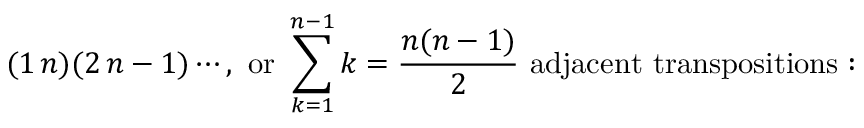Convert formula to latex. <formula><loc_0><loc_0><loc_500><loc_500>( 1 \, n ) ( 2 \, n - 1 ) \cdots , { o r } \sum _ { k = 1 } ^ { n - 1 } k = { \frac { n ( n - 1 ) } { 2 } } { a d j a c e n t t r a n s p o s i t i o n s \colon }</formula> 